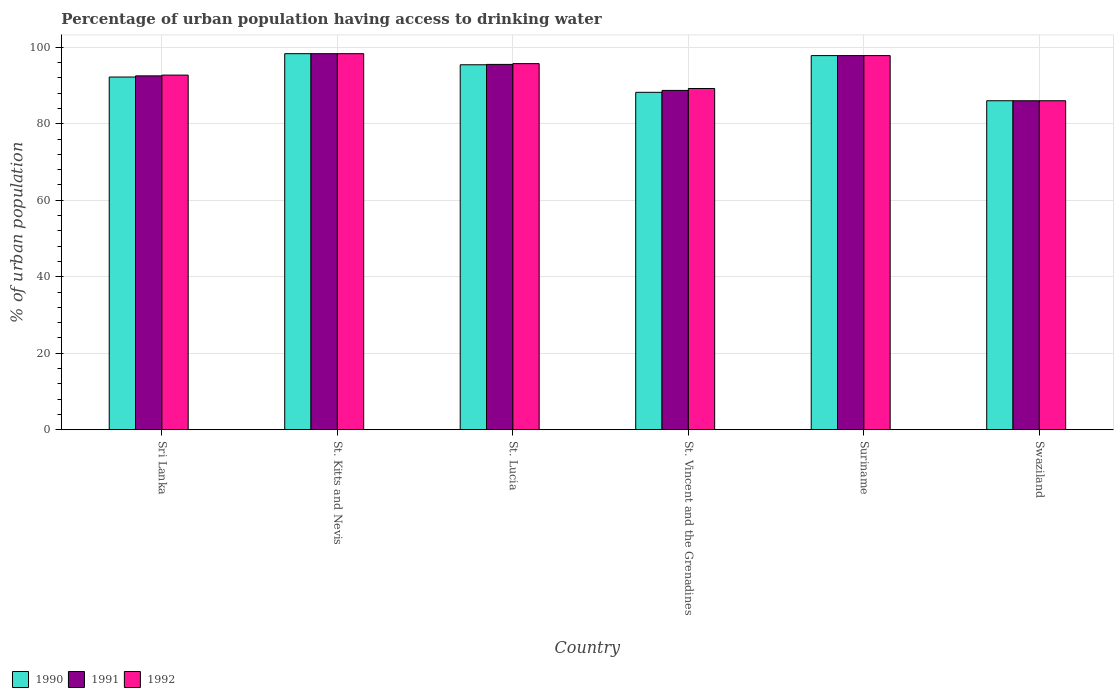How many groups of bars are there?
Provide a succinct answer. 6. What is the label of the 3rd group of bars from the left?
Make the answer very short. St. Lucia. In how many cases, is the number of bars for a given country not equal to the number of legend labels?
Your response must be concise. 0. Across all countries, what is the maximum percentage of urban population having access to drinking water in 1991?
Ensure brevity in your answer.  98.3. In which country was the percentage of urban population having access to drinking water in 1990 maximum?
Your answer should be compact. St. Kitts and Nevis. In which country was the percentage of urban population having access to drinking water in 1991 minimum?
Ensure brevity in your answer.  Swaziland. What is the total percentage of urban population having access to drinking water in 1991 in the graph?
Your answer should be compact. 558.8. What is the difference between the percentage of urban population having access to drinking water in 1992 in St. Lucia and that in St. Vincent and the Grenadines?
Your response must be concise. 6.5. What is the difference between the percentage of urban population having access to drinking water in 1991 in Swaziland and the percentage of urban population having access to drinking water in 1990 in St. Vincent and the Grenadines?
Your answer should be very brief. -2.2. What is the average percentage of urban population having access to drinking water in 1992 per country?
Keep it short and to the point. 93.28. What is the difference between the percentage of urban population having access to drinking water of/in 1991 and percentage of urban population having access to drinking water of/in 1990 in St. Lucia?
Make the answer very short. 0.1. What is the ratio of the percentage of urban population having access to drinking water in 1990 in St. Kitts and Nevis to that in St. Vincent and the Grenadines?
Make the answer very short. 1.11. Is the difference between the percentage of urban population having access to drinking water in 1991 in St. Lucia and Suriname greater than the difference between the percentage of urban population having access to drinking water in 1990 in St. Lucia and Suriname?
Make the answer very short. Yes. What is the difference between the highest and the second highest percentage of urban population having access to drinking water in 1990?
Your answer should be compact. -0.5. What is the difference between the highest and the lowest percentage of urban population having access to drinking water in 1992?
Make the answer very short. 12.3. In how many countries, is the percentage of urban population having access to drinking water in 1990 greater than the average percentage of urban population having access to drinking water in 1990 taken over all countries?
Make the answer very short. 3. What does the 3rd bar from the left in St. Kitts and Nevis represents?
Ensure brevity in your answer.  1992. Is it the case that in every country, the sum of the percentage of urban population having access to drinking water in 1990 and percentage of urban population having access to drinking water in 1991 is greater than the percentage of urban population having access to drinking water in 1992?
Your response must be concise. Yes. How many bars are there?
Your answer should be compact. 18. How many countries are there in the graph?
Offer a terse response. 6. What is the difference between two consecutive major ticks on the Y-axis?
Give a very brief answer. 20. Are the values on the major ticks of Y-axis written in scientific E-notation?
Your response must be concise. No. Does the graph contain any zero values?
Give a very brief answer. No. What is the title of the graph?
Offer a very short reply. Percentage of urban population having access to drinking water. What is the label or title of the Y-axis?
Make the answer very short. % of urban population. What is the % of urban population of 1990 in Sri Lanka?
Provide a short and direct response. 92.2. What is the % of urban population in 1991 in Sri Lanka?
Ensure brevity in your answer.  92.5. What is the % of urban population of 1992 in Sri Lanka?
Offer a terse response. 92.7. What is the % of urban population in 1990 in St. Kitts and Nevis?
Your response must be concise. 98.3. What is the % of urban population of 1991 in St. Kitts and Nevis?
Your answer should be very brief. 98.3. What is the % of urban population in 1992 in St. Kitts and Nevis?
Your response must be concise. 98.3. What is the % of urban population in 1990 in St. Lucia?
Keep it short and to the point. 95.4. What is the % of urban population in 1991 in St. Lucia?
Ensure brevity in your answer.  95.5. What is the % of urban population in 1992 in St. Lucia?
Ensure brevity in your answer.  95.7. What is the % of urban population of 1990 in St. Vincent and the Grenadines?
Make the answer very short. 88.2. What is the % of urban population in 1991 in St. Vincent and the Grenadines?
Provide a short and direct response. 88.7. What is the % of urban population of 1992 in St. Vincent and the Grenadines?
Your answer should be compact. 89.2. What is the % of urban population in 1990 in Suriname?
Your answer should be very brief. 97.8. What is the % of urban population of 1991 in Suriname?
Offer a very short reply. 97.8. What is the % of urban population in 1992 in Suriname?
Offer a terse response. 97.8. What is the % of urban population of 1990 in Swaziland?
Ensure brevity in your answer.  86. Across all countries, what is the maximum % of urban population in 1990?
Ensure brevity in your answer.  98.3. Across all countries, what is the maximum % of urban population in 1991?
Keep it short and to the point. 98.3. Across all countries, what is the maximum % of urban population of 1992?
Ensure brevity in your answer.  98.3. Across all countries, what is the minimum % of urban population of 1990?
Make the answer very short. 86. Across all countries, what is the minimum % of urban population of 1991?
Offer a very short reply. 86. Across all countries, what is the minimum % of urban population of 1992?
Give a very brief answer. 86. What is the total % of urban population of 1990 in the graph?
Provide a succinct answer. 557.9. What is the total % of urban population in 1991 in the graph?
Offer a terse response. 558.8. What is the total % of urban population in 1992 in the graph?
Offer a terse response. 559.7. What is the difference between the % of urban population of 1990 in Sri Lanka and that in St. Kitts and Nevis?
Your answer should be very brief. -6.1. What is the difference between the % of urban population of 1990 in Sri Lanka and that in St. Lucia?
Your response must be concise. -3.2. What is the difference between the % of urban population of 1991 in Sri Lanka and that in St. Lucia?
Your response must be concise. -3. What is the difference between the % of urban population in 1991 in Sri Lanka and that in Suriname?
Provide a succinct answer. -5.3. What is the difference between the % of urban population in 1990 in Sri Lanka and that in Swaziland?
Your answer should be very brief. 6.2. What is the difference between the % of urban population of 1992 in Sri Lanka and that in Swaziland?
Your answer should be compact. 6.7. What is the difference between the % of urban population of 1990 in St. Kitts and Nevis and that in St. Lucia?
Ensure brevity in your answer.  2.9. What is the difference between the % of urban population in 1992 in St. Kitts and Nevis and that in St. Lucia?
Give a very brief answer. 2.6. What is the difference between the % of urban population of 1990 in St. Kitts and Nevis and that in St. Vincent and the Grenadines?
Ensure brevity in your answer.  10.1. What is the difference between the % of urban population of 1992 in St. Kitts and Nevis and that in St. Vincent and the Grenadines?
Provide a short and direct response. 9.1. What is the difference between the % of urban population of 1990 in St. Kitts and Nevis and that in Swaziland?
Your response must be concise. 12.3. What is the difference between the % of urban population of 1991 in St. Kitts and Nevis and that in Swaziland?
Provide a succinct answer. 12.3. What is the difference between the % of urban population in 1991 in St. Lucia and that in St. Vincent and the Grenadines?
Your answer should be very brief. 6.8. What is the difference between the % of urban population of 1992 in St. Lucia and that in St. Vincent and the Grenadines?
Offer a terse response. 6.5. What is the difference between the % of urban population in 1991 in St. Lucia and that in Suriname?
Your response must be concise. -2.3. What is the difference between the % of urban population of 1990 in St. Lucia and that in Swaziland?
Your response must be concise. 9.4. What is the difference between the % of urban population of 1991 in St. Lucia and that in Swaziland?
Provide a short and direct response. 9.5. What is the difference between the % of urban population of 1991 in St. Vincent and the Grenadines and that in Suriname?
Keep it short and to the point. -9.1. What is the difference between the % of urban population of 1992 in St. Vincent and the Grenadines and that in Suriname?
Your answer should be very brief. -8.6. What is the difference between the % of urban population in 1990 in St. Vincent and the Grenadines and that in Swaziland?
Offer a terse response. 2.2. What is the difference between the % of urban population in 1991 in St. Vincent and the Grenadines and that in Swaziland?
Ensure brevity in your answer.  2.7. What is the difference between the % of urban population in 1991 in Suriname and that in Swaziland?
Offer a terse response. 11.8. What is the difference between the % of urban population of 1990 in Sri Lanka and the % of urban population of 1991 in St. Kitts and Nevis?
Keep it short and to the point. -6.1. What is the difference between the % of urban population in 1990 in Sri Lanka and the % of urban population in 1992 in St. Lucia?
Offer a very short reply. -3.5. What is the difference between the % of urban population of 1991 in Sri Lanka and the % of urban population of 1992 in St. Lucia?
Offer a terse response. -3.2. What is the difference between the % of urban population in 1990 in Sri Lanka and the % of urban population in 1991 in Suriname?
Keep it short and to the point. -5.6. What is the difference between the % of urban population of 1990 in Sri Lanka and the % of urban population of 1991 in Swaziland?
Offer a very short reply. 6.2. What is the difference between the % of urban population of 1991 in Sri Lanka and the % of urban population of 1992 in Swaziland?
Your answer should be compact. 6.5. What is the difference between the % of urban population of 1990 in St. Kitts and Nevis and the % of urban population of 1991 in St. Lucia?
Your response must be concise. 2.8. What is the difference between the % of urban population in 1990 in St. Kitts and Nevis and the % of urban population in 1992 in Suriname?
Offer a very short reply. 0.5. What is the difference between the % of urban population of 1991 in St. Kitts and Nevis and the % of urban population of 1992 in Suriname?
Provide a succinct answer. 0.5. What is the difference between the % of urban population in 1990 in St. Kitts and Nevis and the % of urban population in 1992 in Swaziland?
Offer a very short reply. 12.3. What is the difference between the % of urban population in 1991 in St. Kitts and Nevis and the % of urban population in 1992 in Swaziland?
Make the answer very short. 12.3. What is the difference between the % of urban population of 1990 in St. Lucia and the % of urban population of 1991 in St. Vincent and the Grenadines?
Ensure brevity in your answer.  6.7. What is the difference between the % of urban population of 1990 in St. Lucia and the % of urban population of 1992 in St. Vincent and the Grenadines?
Make the answer very short. 6.2. What is the difference between the % of urban population in 1991 in St. Lucia and the % of urban population in 1992 in St. Vincent and the Grenadines?
Provide a short and direct response. 6.3. What is the difference between the % of urban population in 1990 in St. Lucia and the % of urban population in 1991 in Suriname?
Make the answer very short. -2.4. What is the difference between the % of urban population of 1991 in St. Lucia and the % of urban population of 1992 in Suriname?
Make the answer very short. -2.3. What is the difference between the % of urban population in 1990 in St. Lucia and the % of urban population in 1992 in Swaziland?
Offer a terse response. 9.4. What is the difference between the % of urban population in 1991 in St. Lucia and the % of urban population in 1992 in Swaziland?
Your answer should be compact. 9.5. What is the difference between the % of urban population of 1990 in St. Vincent and the Grenadines and the % of urban population of 1991 in Suriname?
Provide a short and direct response. -9.6. What is the difference between the % of urban population in 1990 in St. Vincent and the Grenadines and the % of urban population in 1992 in Suriname?
Offer a very short reply. -9.6. What is the difference between the % of urban population in 1991 in St. Vincent and the Grenadines and the % of urban population in 1992 in Suriname?
Offer a terse response. -9.1. What is the difference between the % of urban population of 1990 in St. Vincent and the Grenadines and the % of urban population of 1991 in Swaziland?
Provide a succinct answer. 2.2. What is the difference between the % of urban population of 1990 in Suriname and the % of urban population of 1991 in Swaziland?
Offer a very short reply. 11.8. What is the average % of urban population in 1990 per country?
Keep it short and to the point. 92.98. What is the average % of urban population of 1991 per country?
Give a very brief answer. 93.13. What is the average % of urban population of 1992 per country?
Offer a very short reply. 93.28. What is the difference between the % of urban population of 1990 and % of urban population of 1991 in Sri Lanka?
Provide a short and direct response. -0.3. What is the difference between the % of urban population of 1990 and % of urban population of 1992 in Sri Lanka?
Keep it short and to the point. -0.5. What is the difference between the % of urban population of 1991 and % of urban population of 1992 in Sri Lanka?
Provide a succinct answer. -0.2. What is the difference between the % of urban population in 1990 and % of urban population in 1991 in St. Kitts and Nevis?
Offer a very short reply. 0. What is the difference between the % of urban population in 1991 and % of urban population in 1992 in St. Kitts and Nevis?
Provide a succinct answer. 0. What is the difference between the % of urban population in 1990 and % of urban population in 1991 in St. Lucia?
Your answer should be compact. -0.1. What is the difference between the % of urban population of 1991 and % of urban population of 1992 in St. Lucia?
Provide a short and direct response. -0.2. What is the difference between the % of urban population of 1990 and % of urban population of 1992 in St. Vincent and the Grenadines?
Your answer should be compact. -1. What is the difference between the % of urban population of 1991 and % of urban population of 1992 in St. Vincent and the Grenadines?
Make the answer very short. -0.5. What is the difference between the % of urban population of 1990 and % of urban population of 1991 in Suriname?
Your answer should be very brief. 0. What is the difference between the % of urban population in 1990 and % of urban population in 1992 in Suriname?
Offer a very short reply. 0. What is the difference between the % of urban population in 1991 and % of urban population in 1992 in Suriname?
Provide a short and direct response. 0. What is the difference between the % of urban population of 1990 and % of urban population of 1992 in Swaziland?
Give a very brief answer. 0. What is the ratio of the % of urban population of 1990 in Sri Lanka to that in St. Kitts and Nevis?
Make the answer very short. 0.94. What is the ratio of the % of urban population in 1991 in Sri Lanka to that in St. Kitts and Nevis?
Offer a very short reply. 0.94. What is the ratio of the % of urban population in 1992 in Sri Lanka to that in St. Kitts and Nevis?
Your answer should be compact. 0.94. What is the ratio of the % of urban population of 1990 in Sri Lanka to that in St. Lucia?
Ensure brevity in your answer.  0.97. What is the ratio of the % of urban population in 1991 in Sri Lanka to that in St. Lucia?
Your answer should be compact. 0.97. What is the ratio of the % of urban population in 1992 in Sri Lanka to that in St. Lucia?
Provide a succinct answer. 0.97. What is the ratio of the % of urban population of 1990 in Sri Lanka to that in St. Vincent and the Grenadines?
Keep it short and to the point. 1.05. What is the ratio of the % of urban population in 1991 in Sri Lanka to that in St. Vincent and the Grenadines?
Your answer should be very brief. 1.04. What is the ratio of the % of urban population in 1992 in Sri Lanka to that in St. Vincent and the Grenadines?
Ensure brevity in your answer.  1.04. What is the ratio of the % of urban population of 1990 in Sri Lanka to that in Suriname?
Keep it short and to the point. 0.94. What is the ratio of the % of urban population in 1991 in Sri Lanka to that in Suriname?
Your response must be concise. 0.95. What is the ratio of the % of urban population in 1992 in Sri Lanka to that in Suriname?
Your answer should be very brief. 0.95. What is the ratio of the % of urban population of 1990 in Sri Lanka to that in Swaziland?
Offer a very short reply. 1.07. What is the ratio of the % of urban population of 1991 in Sri Lanka to that in Swaziland?
Provide a short and direct response. 1.08. What is the ratio of the % of urban population of 1992 in Sri Lanka to that in Swaziland?
Offer a terse response. 1.08. What is the ratio of the % of urban population of 1990 in St. Kitts and Nevis to that in St. Lucia?
Offer a very short reply. 1.03. What is the ratio of the % of urban population of 1991 in St. Kitts and Nevis to that in St. Lucia?
Your response must be concise. 1.03. What is the ratio of the % of urban population of 1992 in St. Kitts and Nevis to that in St. Lucia?
Give a very brief answer. 1.03. What is the ratio of the % of urban population in 1990 in St. Kitts and Nevis to that in St. Vincent and the Grenadines?
Your answer should be very brief. 1.11. What is the ratio of the % of urban population in 1991 in St. Kitts and Nevis to that in St. Vincent and the Grenadines?
Your answer should be compact. 1.11. What is the ratio of the % of urban population in 1992 in St. Kitts and Nevis to that in St. Vincent and the Grenadines?
Your answer should be compact. 1.1. What is the ratio of the % of urban population of 1991 in St. Kitts and Nevis to that in Suriname?
Provide a succinct answer. 1.01. What is the ratio of the % of urban population of 1992 in St. Kitts and Nevis to that in Suriname?
Your answer should be very brief. 1.01. What is the ratio of the % of urban population of 1990 in St. Kitts and Nevis to that in Swaziland?
Offer a terse response. 1.14. What is the ratio of the % of urban population in 1991 in St. Kitts and Nevis to that in Swaziland?
Make the answer very short. 1.14. What is the ratio of the % of urban population in 1992 in St. Kitts and Nevis to that in Swaziland?
Your answer should be very brief. 1.14. What is the ratio of the % of urban population of 1990 in St. Lucia to that in St. Vincent and the Grenadines?
Offer a terse response. 1.08. What is the ratio of the % of urban population in 1991 in St. Lucia to that in St. Vincent and the Grenadines?
Provide a succinct answer. 1.08. What is the ratio of the % of urban population in 1992 in St. Lucia to that in St. Vincent and the Grenadines?
Your response must be concise. 1.07. What is the ratio of the % of urban population in 1990 in St. Lucia to that in Suriname?
Your answer should be very brief. 0.98. What is the ratio of the % of urban population of 1991 in St. Lucia to that in Suriname?
Offer a terse response. 0.98. What is the ratio of the % of urban population in 1992 in St. Lucia to that in Suriname?
Make the answer very short. 0.98. What is the ratio of the % of urban population of 1990 in St. Lucia to that in Swaziland?
Provide a succinct answer. 1.11. What is the ratio of the % of urban population of 1991 in St. Lucia to that in Swaziland?
Your answer should be very brief. 1.11. What is the ratio of the % of urban population of 1992 in St. Lucia to that in Swaziland?
Provide a succinct answer. 1.11. What is the ratio of the % of urban population of 1990 in St. Vincent and the Grenadines to that in Suriname?
Make the answer very short. 0.9. What is the ratio of the % of urban population in 1991 in St. Vincent and the Grenadines to that in Suriname?
Give a very brief answer. 0.91. What is the ratio of the % of urban population of 1992 in St. Vincent and the Grenadines to that in Suriname?
Your response must be concise. 0.91. What is the ratio of the % of urban population of 1990 in St. Vincent and the Grenadines to that in Swaziland?
Keep it short and to the point. 1.03. What is the ratio of the % of urban population in 1991 in St. Vincent and the Grenadines to that in Swaziland?
Make the answer very short. 1.03. What is the ratio of the % of urban population in 1992 in St. Vincent and the Grenadines to that in Swaziland?
Give a very brief answer. 1.04. What is the ratio of the % of urban population in 1990 in Suriname to that in Swaziland?
Give a very brief answer. 1.14. What is the ratio of the % of urban population of 1991 in Suriname to that in Swaziland?
Give a very brief answer. 1.14. What is the ratio of the % of urban population of 1992 in Suriname to that in Swaziland?
Your response must be concise. 1.14. What is the difference between the highest and the second highest % of urban population in 1990?
Your answer should be very brief. 0.5. What is the difference between the highest and the second highest % of urban population in 1991?
Ensure brevity in your answer.  0.5. What is the difference between the highest and the second highest % of urban population of 1992?
Ensure brevity in your answer.  0.5. What is the difference between the highest and the lowest % of urban population of 1991?
Offer a very short reply. 12.3. 